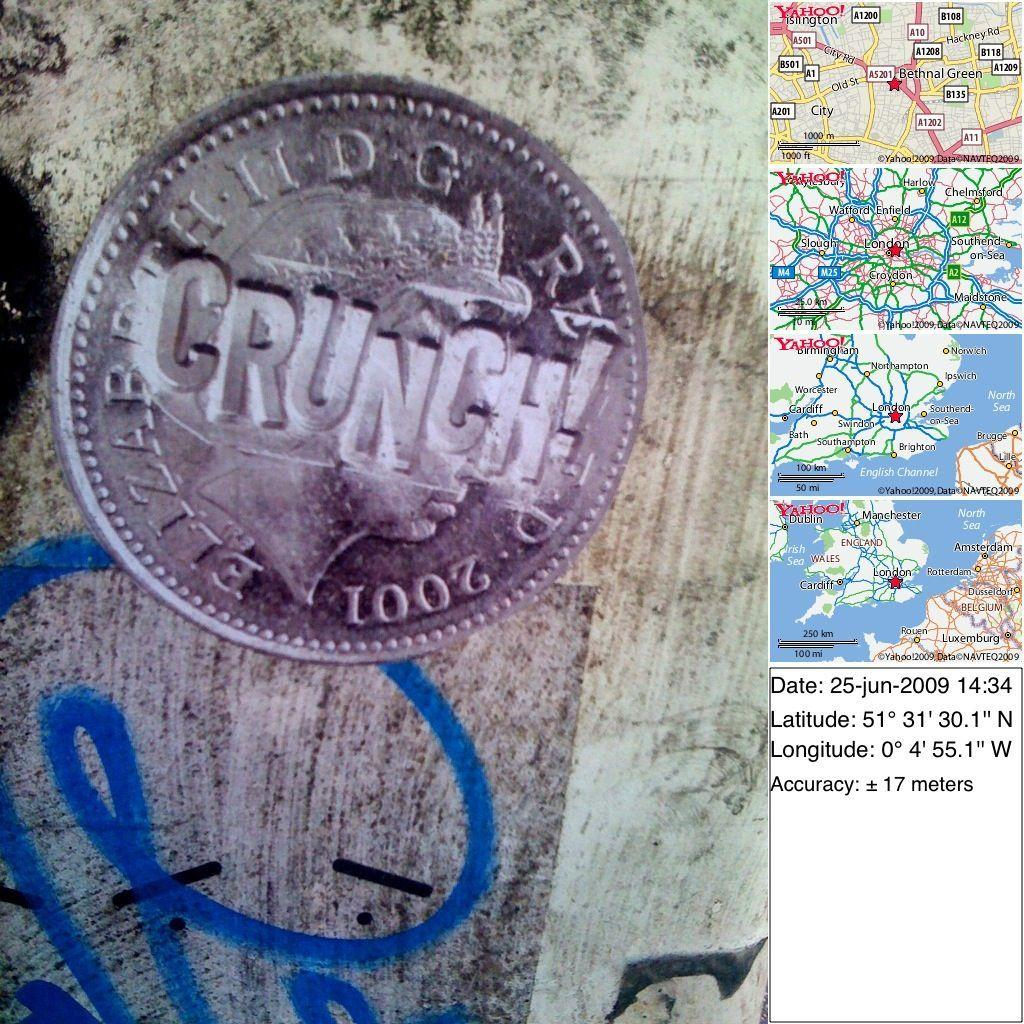<image>
Describe the image concisely. A 2001 coin is next to a series of maps and coordinates. 